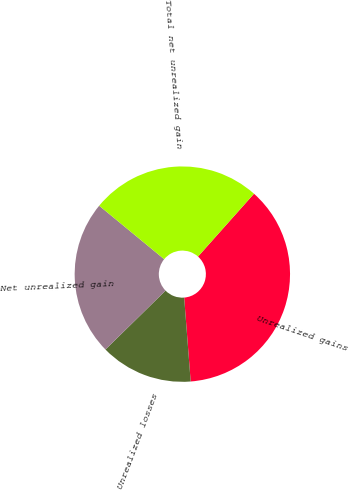Convert chart to OTSL. <chart><loc_0><loc_0><loc_500><loc_500><pie_chart><fcel>Unrealized gains<fcel>Unrealized losses<fcel>Net unrealized gain<fcel>Total net unrealized gain<nl><fcel>37.19%<fcel>13.89%<fcel>23.3%<fcel>25.63%<nl></chart> 